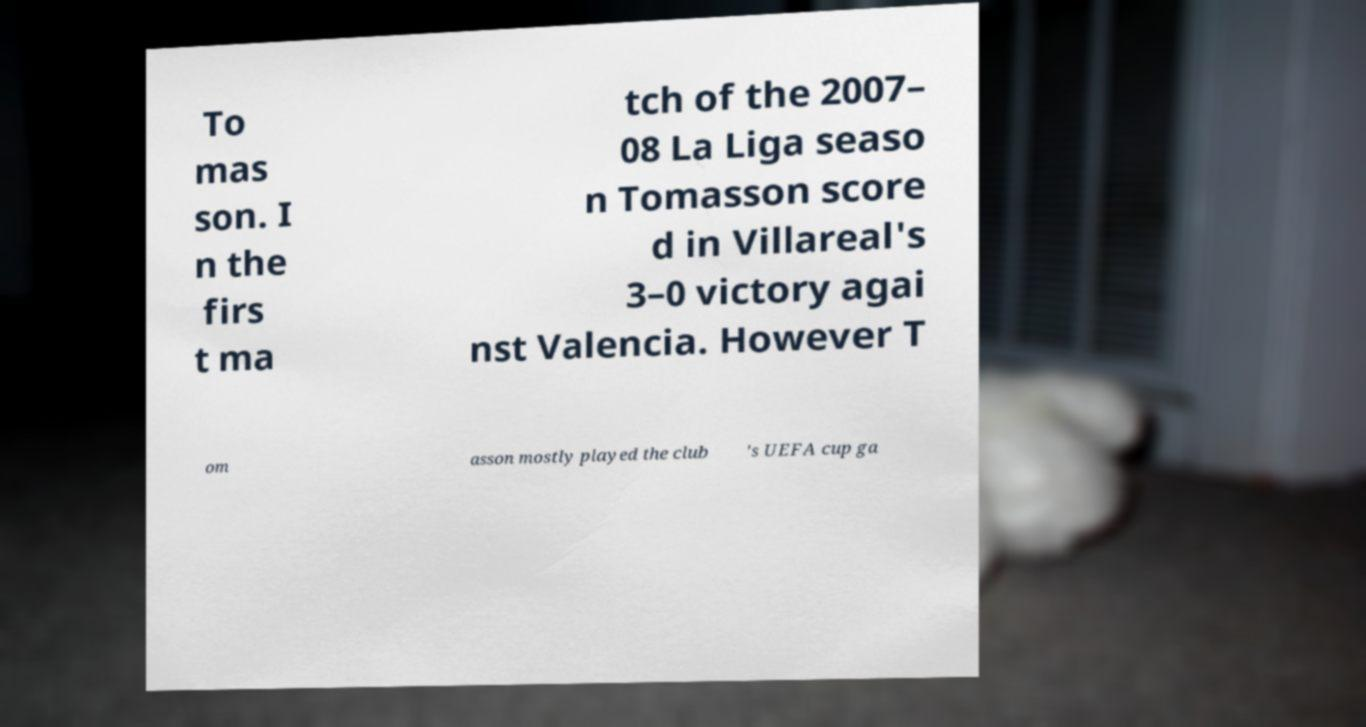What messages or text are displayed in this image? I need them in a readable, typed format. To mas son. I n the firs t ma tch of the 2007– 08 La Liga seaso n Tomasson score d in Villareal's 3–0 victory agai nst Valencia. However T om asson mostly played the club 's UEFA cup ga 